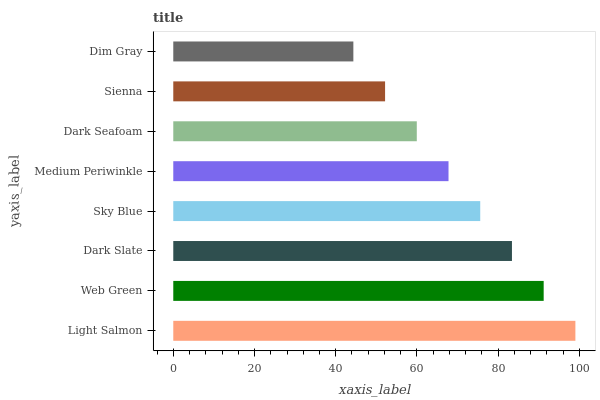Is Dim Gray the minimum?
Answer yes or no. Yes. Is Light Salmon the maximum?
Answer yes or no. Yes. Is Web Green the minimum?
Answer yes or no. No. Is Web Green the maximum?
Answer yes or no. No. Is Light Salmon greater than Web Green?
Answer yes or no. Yes. Is Web Green less than Light Salmon?
Answer yes or no. Yes. Is Web Green greater than Light Salmon?
Answer yes or no. No. Is Light Salmon less than Web Green?
Answer yes or no. No. Is Sky Blue the high median?
Answer yes or no. Yes. Is Medium Periwinkle the low median?
Answer yes or no. Yes. Is Dark Seafoam the high median?
Answer yes or no. No. Is Dark Seafoam the low median?
Answer yes or no. No. 